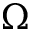Convert formula to latex. <formula><loc_0><loc_0><loc_500><loc_500>\Omega</formula> 